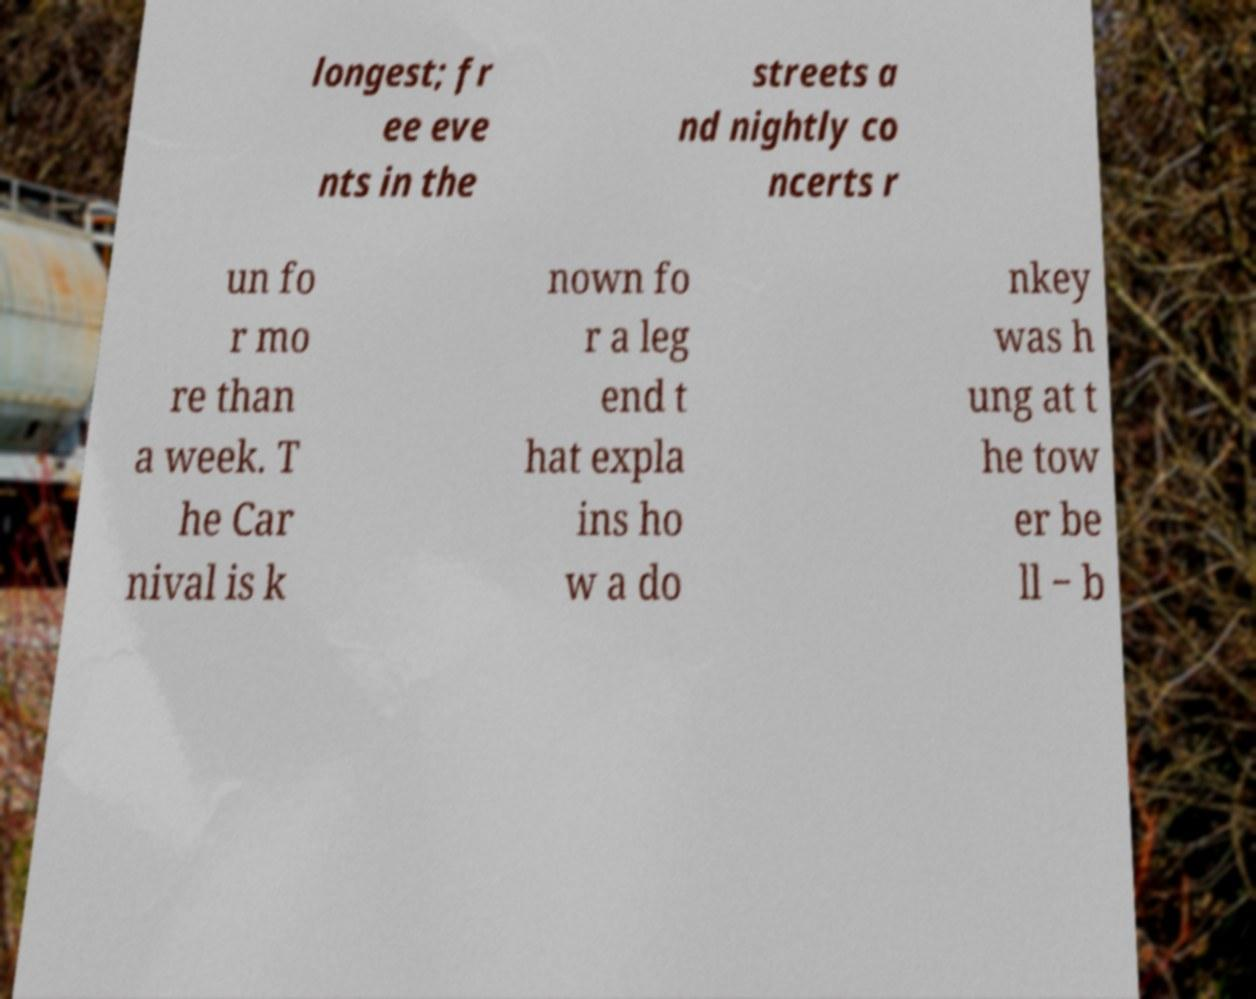For documentation purposes, I need the text within this image transcribed. Could you provide that? longest; fr ee eve nts in the streets a nd nightly co ncerts r un fo r mo re than a week. T he Car nival is k nown fo r a leg end t hat expla ins ho w a do nkey was h ung at t he tow er be ll − b 